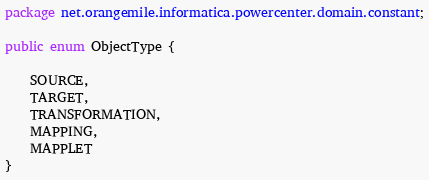<code> <loc_0><loc_0><loc_500><loc_500><_Java_>package net.orangemile.informatica.powercenter.domain.constant;

public enum ObjectType {

	SOURCE,
	TARGET,
	TRANSFORMATION,
	MAPPING,
	MAPPLET
}
</code> 